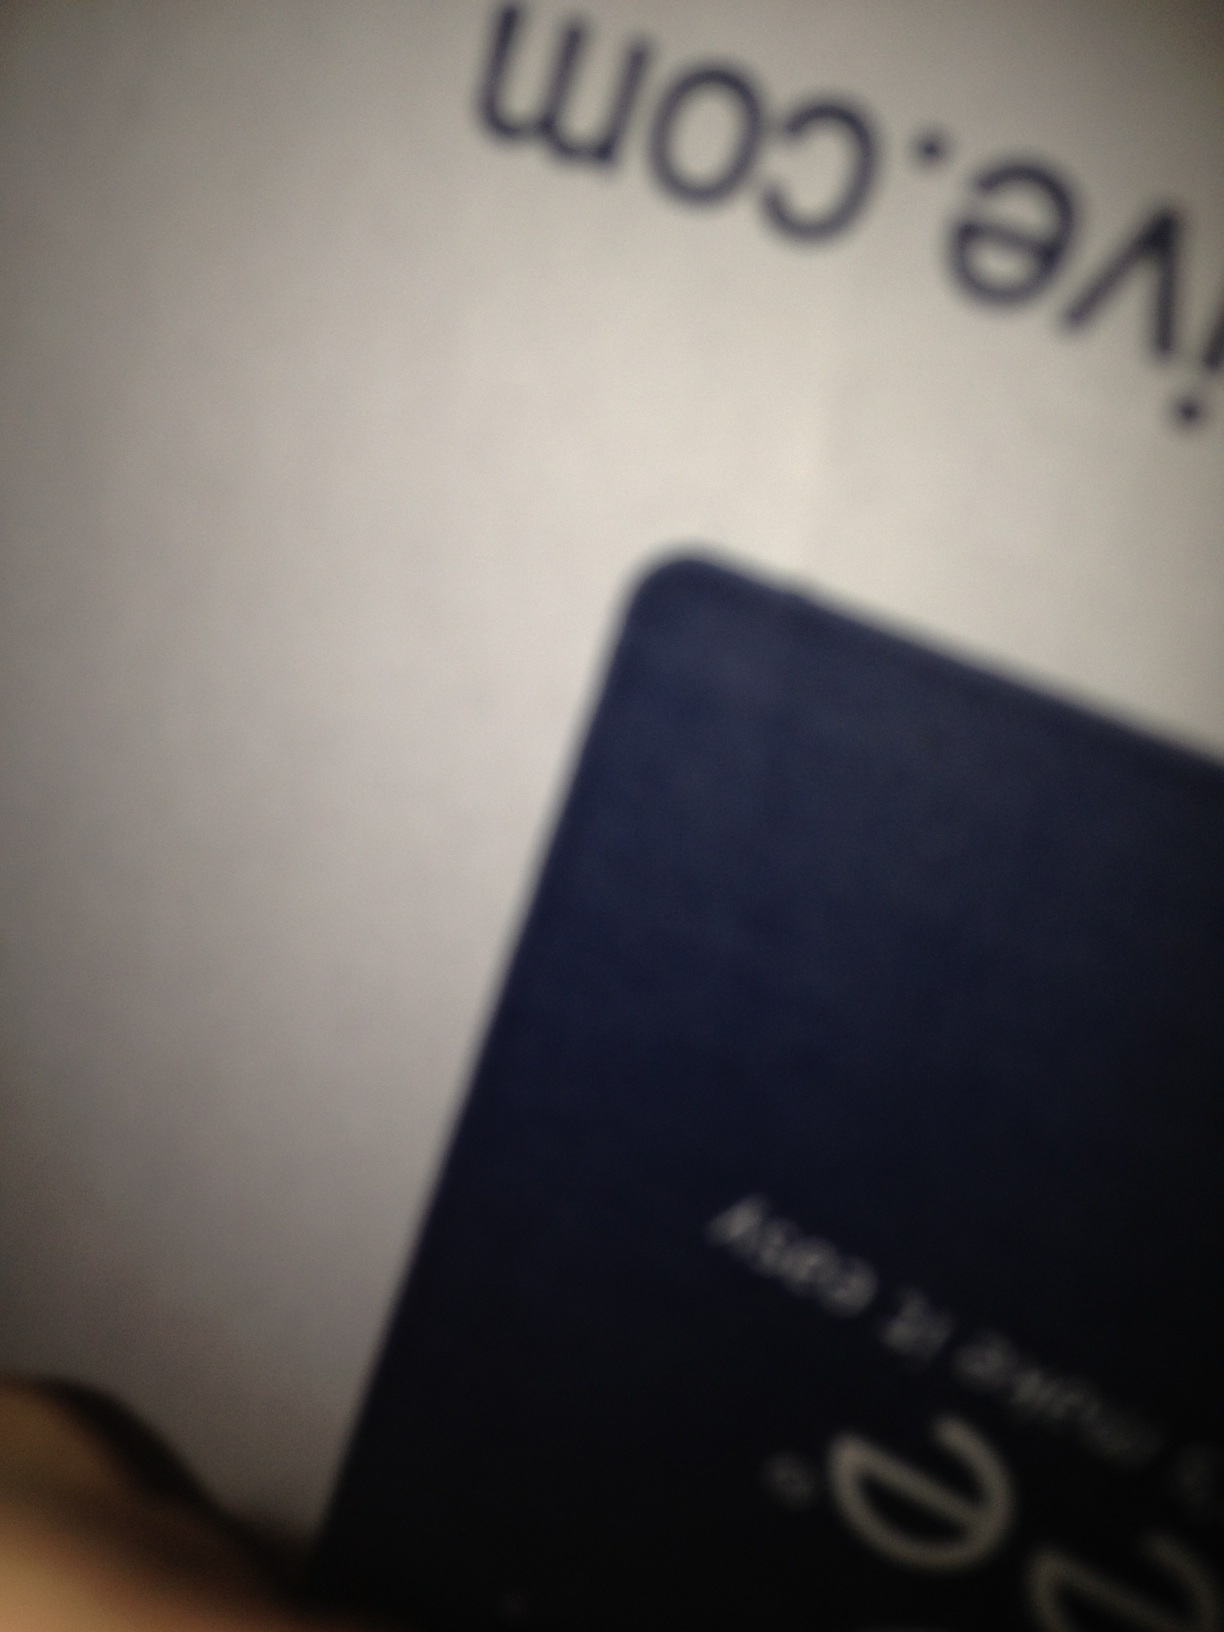What might be the general use of such a box based on its shape and appearance? Based on its size and general appearance, this could be a box used for packaging electronic devices like phones or small tablets. These boxes are typically sturdy to protect the contents during shipping. 